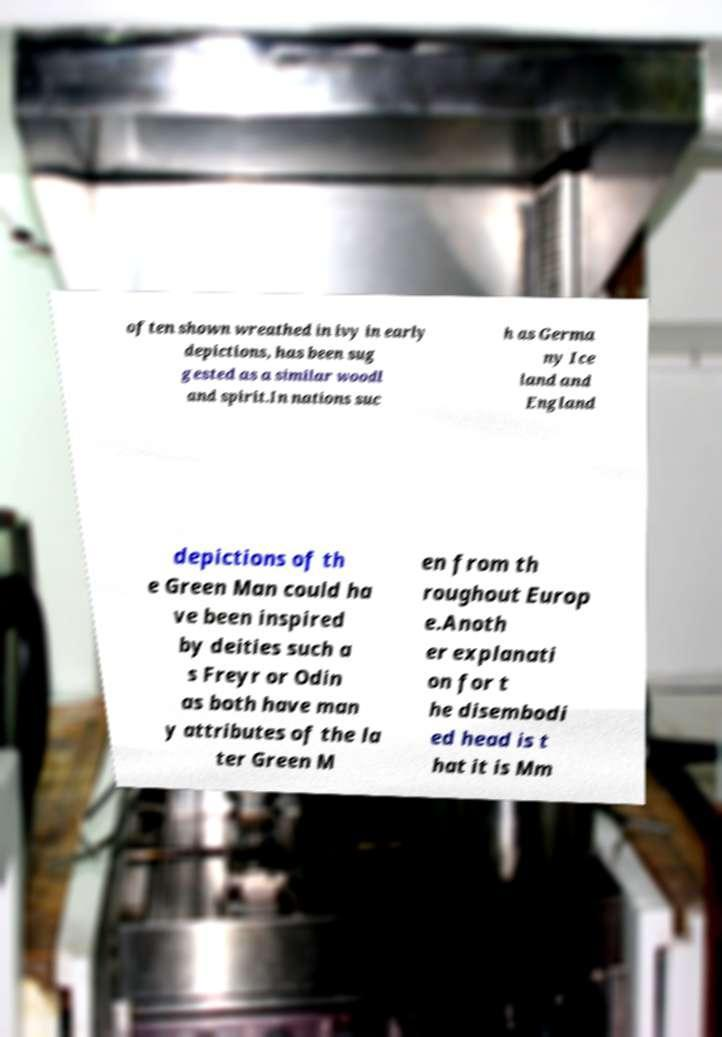Please read and relay the text visible in this image. What does it say? often shown wreathed in ivy in early depictions, has been sug gested as a similar woodl and spirit.In nations suc h as Germa ny Ice land and England depictions of th e Green Man could ha ve been inspired by deities such a s Freyr or Odin as both have man y attributes of the la ter Green M en from th roughout Europ e.Anoth er explanati on for t he disembodi ed head is t hat it is Mm 